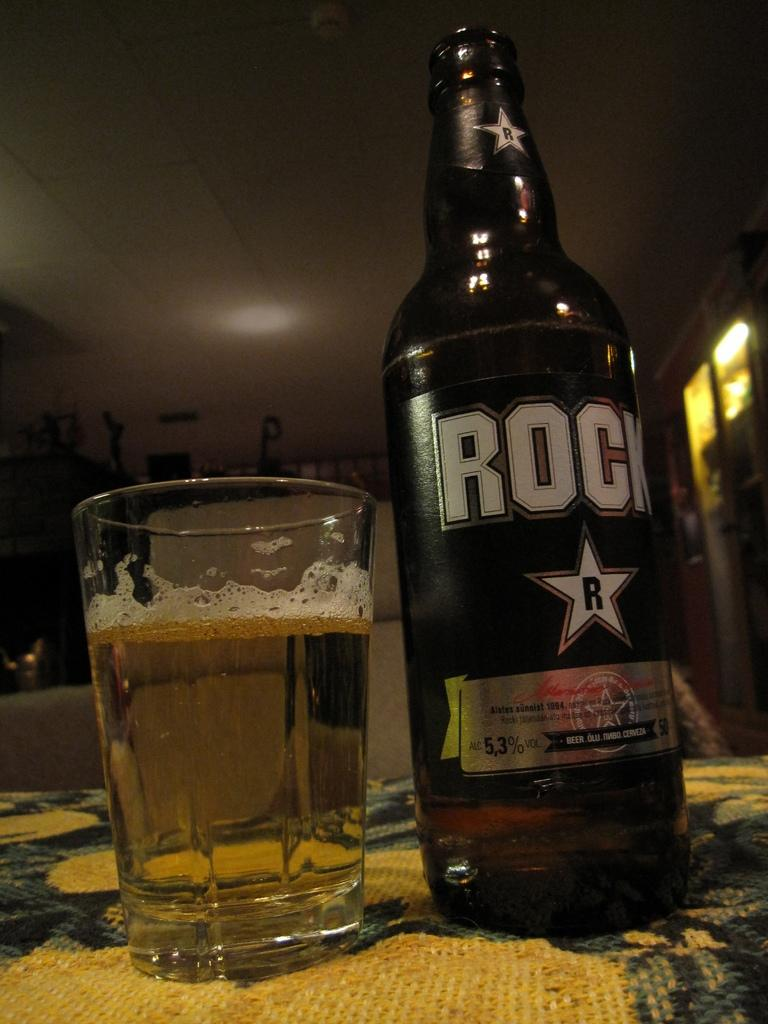<image>
Render a clear and concise summary of the photo. A bottle of Rock Star beer next to a glass 